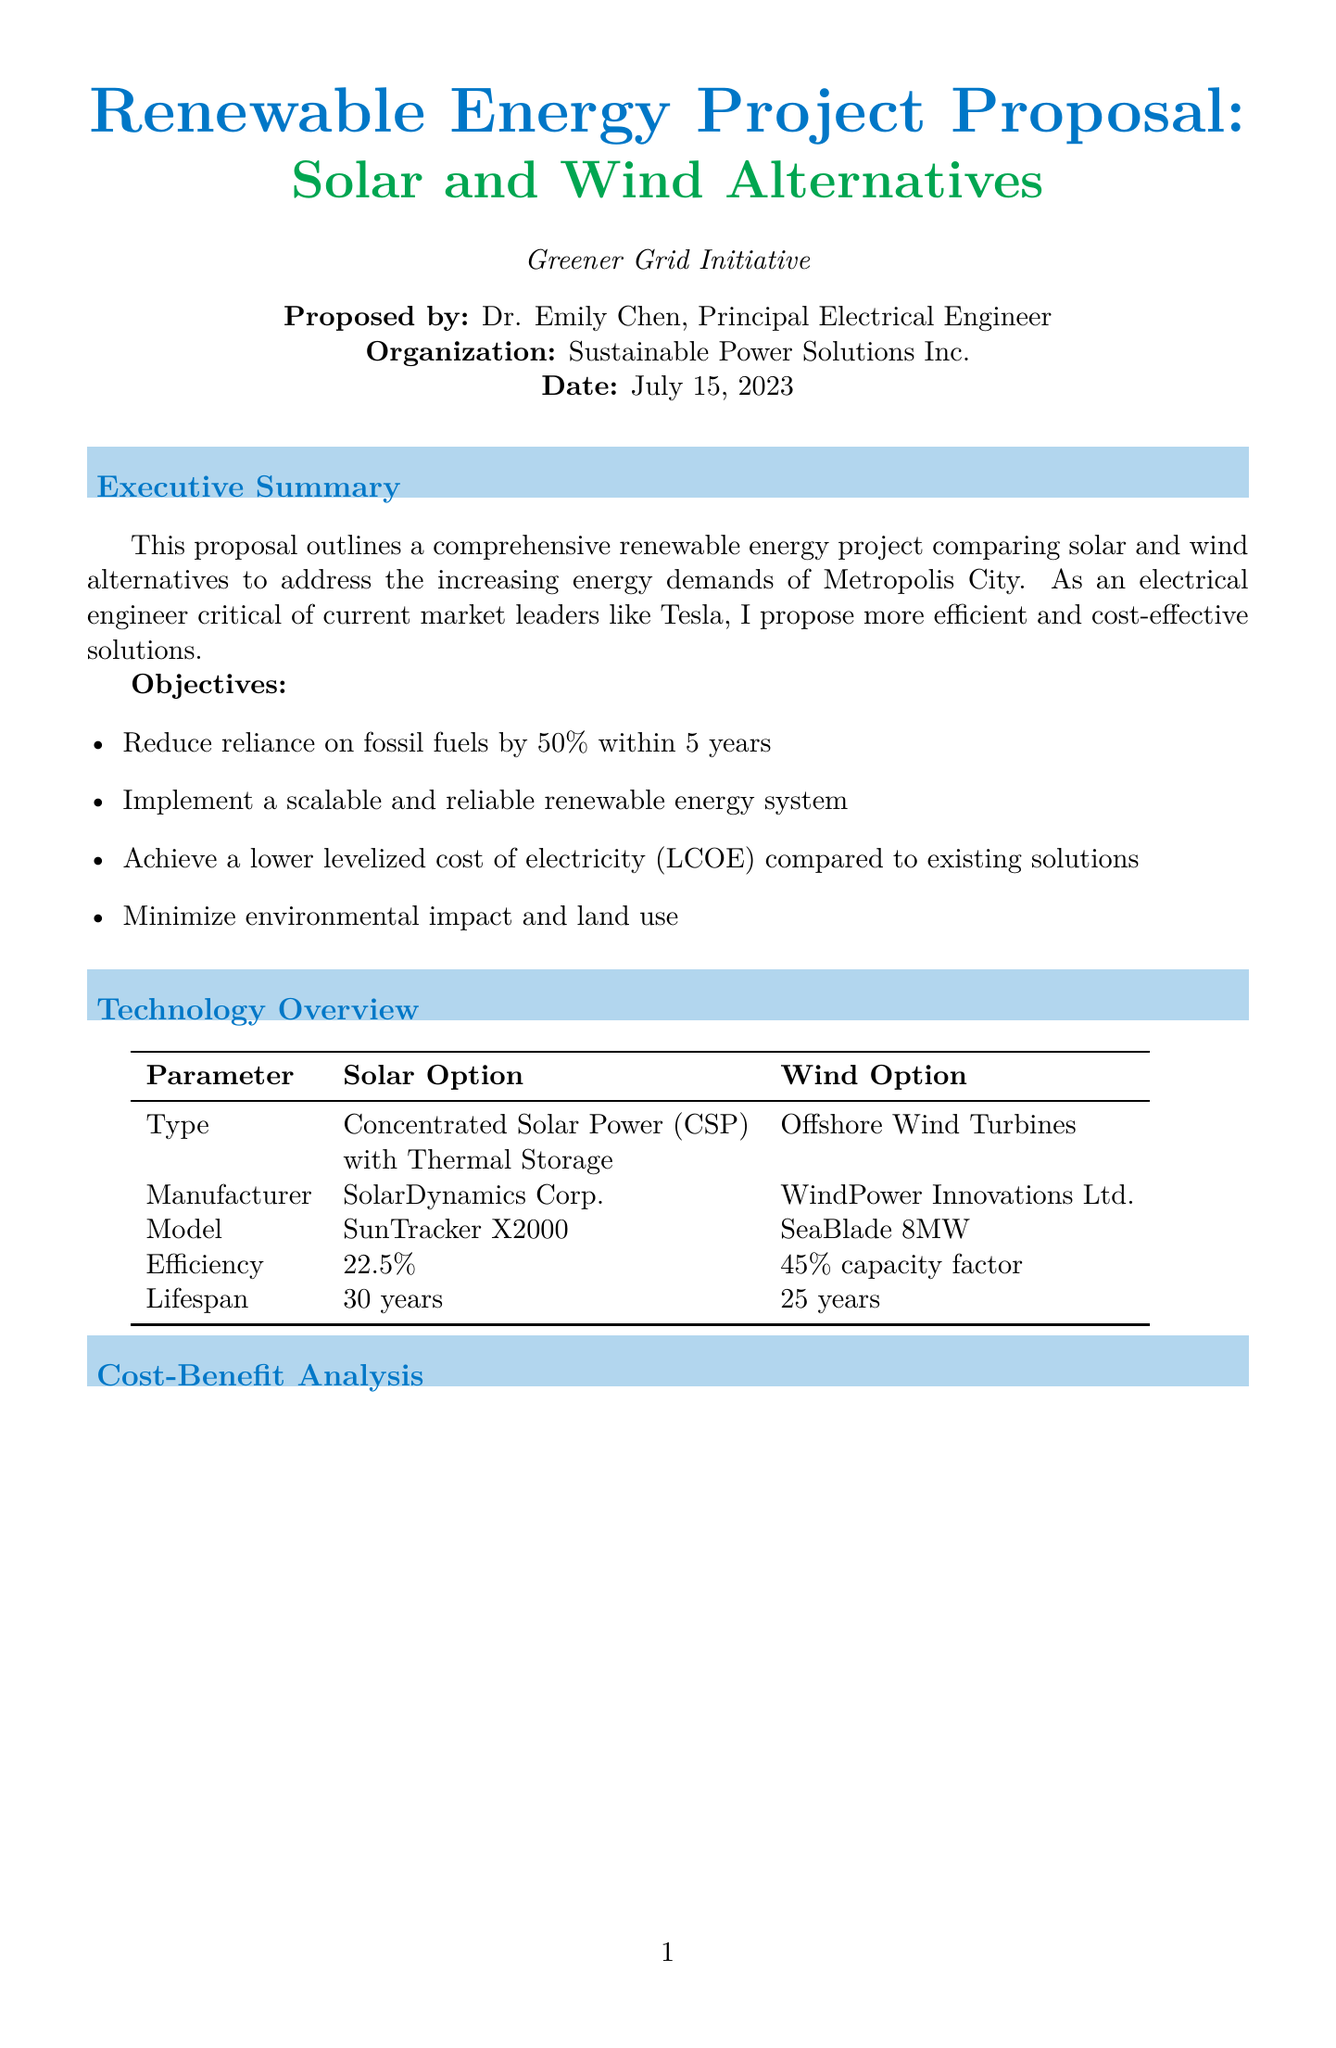what is the project name? The project name is stated in the project information section of the document.
Answer: Greener Grid Initiative who proposed the project? The name of the individual proposing the project is specified in the project information section.
Answer: Dr. Emily Chen what is the initial investment for solar equipment? The initial investment amount for the solar equipment is found in the cost-benefit analysis.
Answer: 450000000 what is the estimated annual revenue for wind? This figure is given in the cost-benefit analysis section under revenue projections for wind.
Answer: 112000000 what is the payback period for solar? The payback period is calculated in the ROI analysis of the cost-benefit analysis section.
Answer: 8.5 years which technology has a higher efficiency? This question compares the efficiency of solar and wind technologies as presented in the technology overview section.
Answer: Wind what environmental benefit does solar provide? This benefit is represented in the environmental impact section regarding carbon offset.
Answer: 800000 tons what is the preferred option stated in the conclusion? The preferred option is directly mentioned in the conclusion and recommendations section.
Answer: Hybrid Solar-Wind Solution what is the primary rationale for the preferred option? The rationale is explained in the conclusion and highlights the advantages of combining technologies.
Answer: More stable and efficient energy mix 